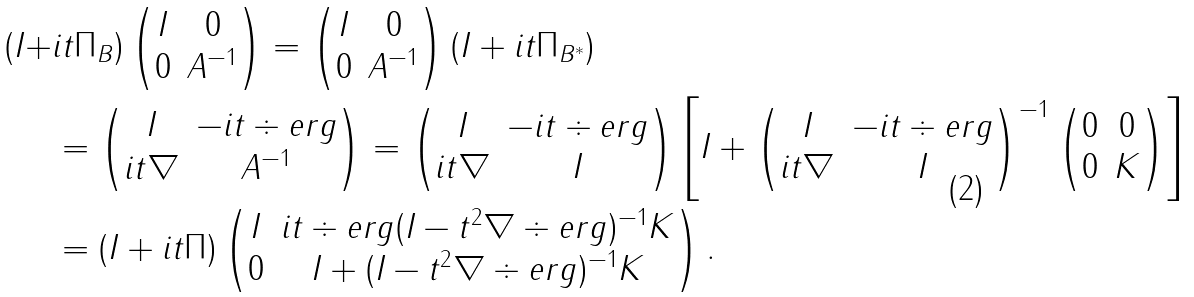<formula> <loc_0><loc_0><loc_500><loc_500>( I + & i t \Pi _ { B } ) \begin{pmatrix} I & 0 \\ 0 & A ^ { - 1 } \end{pmatrix} = \begin{pmatrix} I & 0 \\ 0 & A ^ { - 1 } \end{pmatrix} ( I + i t \Pi _ { B ^ { * } } ) \\ & = \begin{pmatrix} I & - i t \div e r g \\ i t \nabla & A ^ { - 1 } \end{pmatrix} = \begin{pmatrix} I & - i t \div e r g \\ i t \nabla & I \end{pmatrix} \left [ I + \begin{pmatrix} I & - i t \div e r g \\ i t \nabla & I \end{pmatrix} ^ { - 1 } \begin{pmatrix} 0 & 0 \\ 0 & K \end{pmatrix} \right ] \\ & = ( I + i t \Pi ) \begin{pmatrix} I & i t \div e r g ( I - t ^ { 2 } \nabla \div e r g ) ^ { - 1 } K \\ 0 & I + ( I - t ^ { 2 } \nabla \div e r g ) ^ { - 1 } K \end{pmatrix} .</formula> 